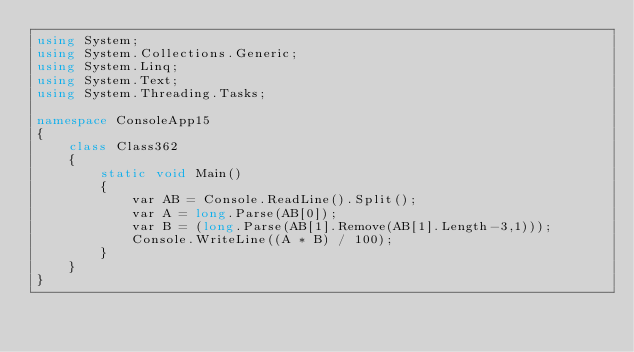Convert code to text. <code><loc_0><loc_0><loc_500><loc_500><_C#_>using System;
using System.Collections.Generic;
using System.Linq;
using System.Text;
using System.Threading.Tasks;

namespace ConsoleApp15
{
    class Class362
    {
        static void Main()
        {
            var AB = Console.ReadLine().Split();
            var A = long.Parse(AB[0]);
            var B = (long.Parse(AB[1].Remove(AB[1].Length-3,1)));
            Console.WriteLine((A * B) / 100);
        }
    }
}
</code> 